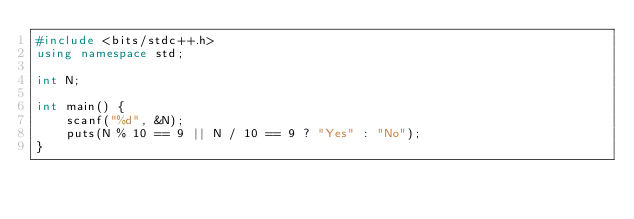<code> <loc_0><loc_0><loc_500><loc_500><_C++_>#include <bits/stdc++.h>
using namespace std;

int N;

int main() {
    scanf("%d", &N);
    puts(N % 10 == 9 || N / 10 == 9 ? "Yes" : "No");
}
</code> 